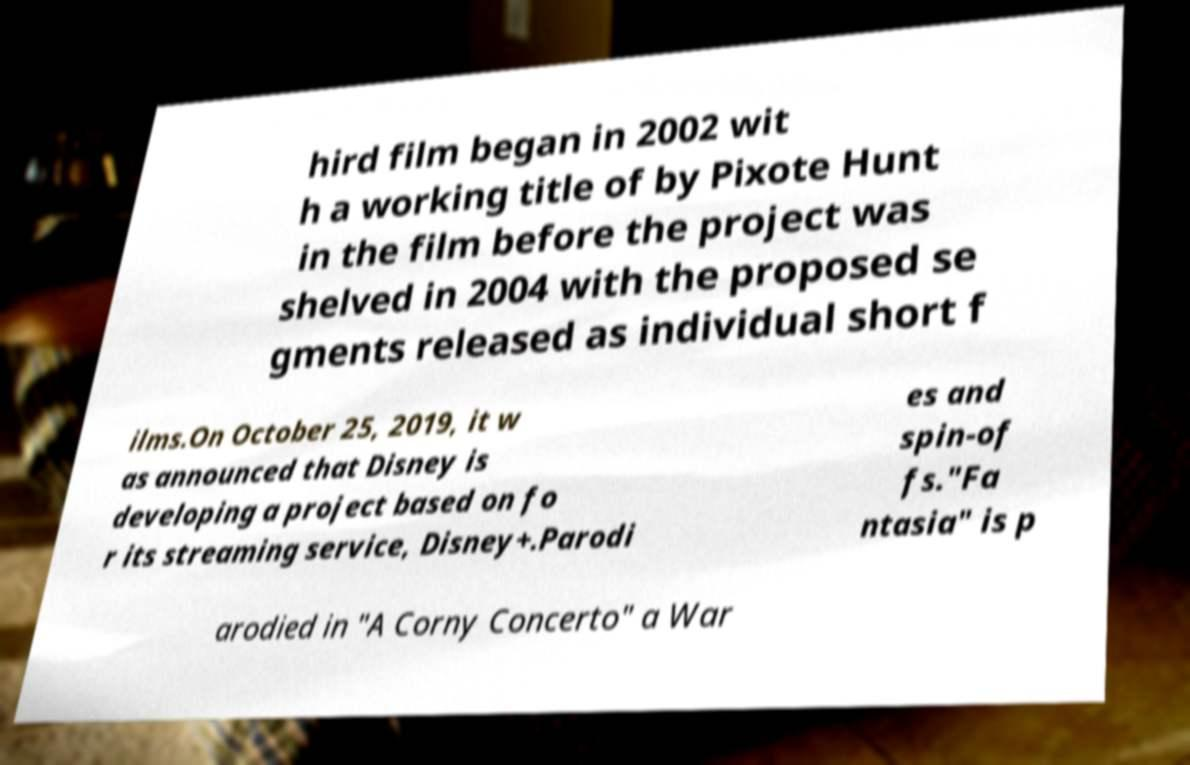Please identify and transcribe the text found in this image. hird film began in 2002 wit h a working title of by Pixote Hunt in the film before the project was shelved in 2004 with the proposed se gments released as individual short f ilms.On October 25, 2019, it w as announced that Disney is developing a project based on fo r its streaming service, Disney+.Parodi es and spin-of fs."Fa ntasia" is p arodied in "A Corny Concerto" a War 